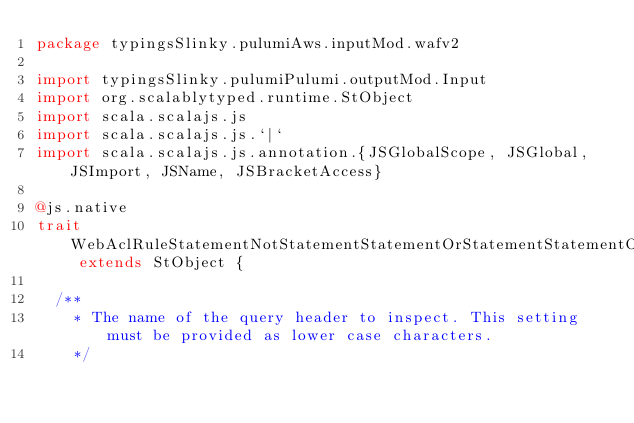<code> <loc_0><loc_0><loc_500><loc_500><_Scala_>package typingsSlinky.pulumiAws.inputMod.wafv2

import typingsSlinky.pulumiPulumi.outputMod.Input
import org.scalablytyped.runtime.StObject
import scala.scalajs.js
import scala.scalajs.js.`|`
import scala.scalajs.js.annotation.{JSGlobalScope, JSGlobal, JSImport, JSName, JSBracketAccess}

@js.native
trait WebAclRuleStatementNotStatementStatementOrStatementStatementOrStatementStatementByteMatchStatementFieldToMatchSingleHeader extends StObject {
  
  /**
    * The name of the query header to inspect. This setting must be provided as lower case characters.
    */</code> 